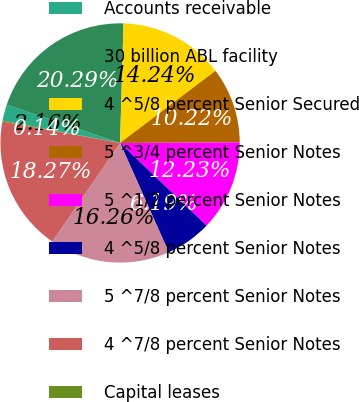Convert chart to OTSL. <chart><loc_0><loc_0><loc_500><loc_500><pie_chart><fcel>Accounts receivable<fcel>30 billion ABL facility<fcel>4 ^5/8 percent Senior Secured<fcel>5 ^3/4 percent Senior Notes<fcel>5 ^1/2 percent Senior Notes<fcel>4 ^5/8 percent Senior Notes<fcel>5 ^7/8 percent Senior Notes<fcel>4 ^7/8 percent Senior Notes<fcel>Capital leases<nl><fcel>2.16%<fcel>20.29%<fcel>14.24%<fcel>10.22%<fcel>12.23%<fcel>6.19%<fcel>16.26%<fcel>18.27%<fcel>0.14%<nl></chart> 